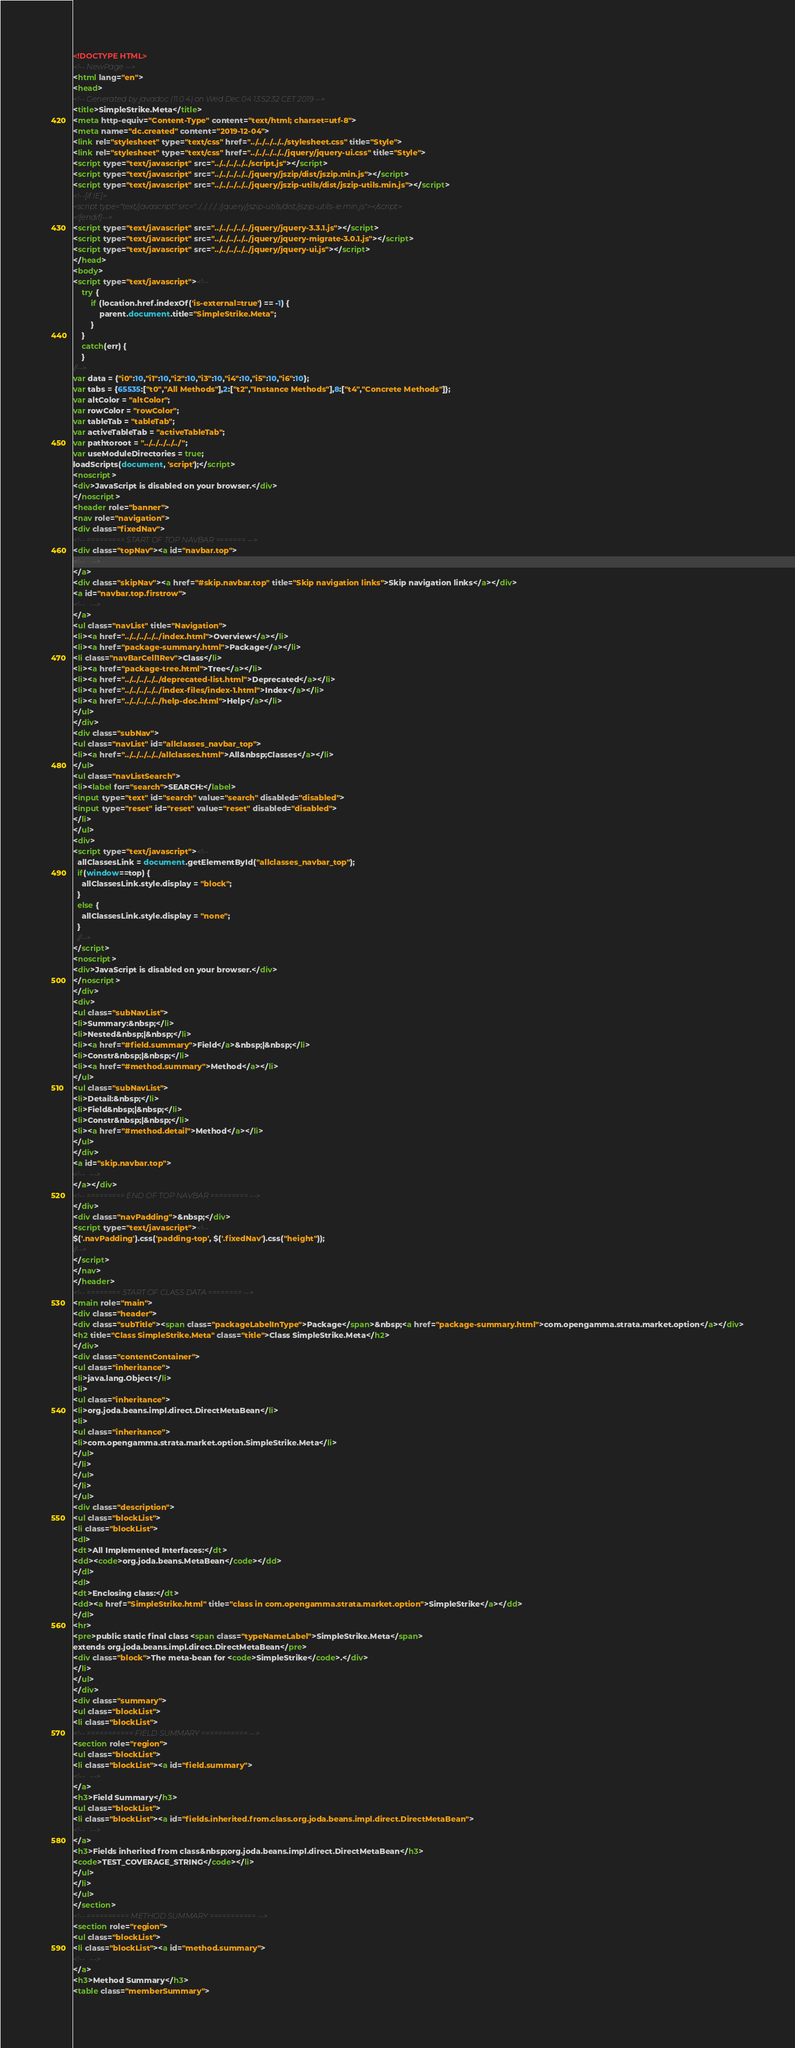Convert code to text. <code><loc_0><loc_0><loc_500><loc_500><_HTML_><!DOCTYPE HTML>
<!-- NewPage -->
<html lang="en">
<head>
<!-- Generated by javadoc (11.0.4) on Wed Dec 04 13:52:32 CET 2019 -->
<title>SimpleStrike.Meta</title>
<meta http-equiv="Content-Type" content="text/html; charset=utf-8">
<meta name="dc.created" content="2019-12-04">
<link rel="stylesheet" type="text/css" href="../../../../../stylesheet.css" title="Style">
<link rel="stylesheet" type="text/css" href="../../../../../jquery/jquery-ui.css" title="Style">
<script type="text/javascript" src="../../../../../script.js"></script>
<script type="text/javascript" src="../../../../../jquery/jszip/dist/jszip.min.js"></script>
<script type="text/javascript" src="../../../../../jquery/jszip-utils/dist/jszip-utils.min.js"></script>
<!--[if IE]>
<script type="text/javascript" src="../../../../../jquery/jszip-utils/dist/jszip-utils-ie.min.js"></script>
<![endif]-->
<script type="text/javascript" src="../../../../../jquery/jquery-3.3.1.js"></script>
<script type="text/javascript" src="../../../../../jquery/jquery-migrate-3.0.1.js"></script>
<script type="text/javascript" src="../../../../../jquery/jquery-ui.js"></script>
</head>
<body>
<script type="text/javascript"><!--
    try {
        if (location.href.indexOf('is-external=true') == -1) {
            parent.document.title="SimpleStrike.Meta";
        }
    }
    catch(err) {
    }
//-->
var data = {"i0":10,"i1":10,"i2":10,"i3":10,"i4":10,"i5":10,"i6":10};
var tabs = {65535:["t0","All Methods"],2:["t2","Instance Methods"],8:["t4","Concrete Methods"]};
var altColor = "altColor";
var rowColor = "rowColor";
var tableTab = "tableTab";
var activeTableTab = "activeTableTab";
var pathtoroot = "../../../../../";
var useModuleDirectories = true;
loadScripts(document, 'script');</script>
<noscript>
<div>JavaScript is disabled on your browser.</div>
</noscript>
<header role="banner">
<nav role="navigation">
<div class="fixedNav">
<!-- ========= START OF TOP NAVBAR ======= -->
<div class="topNav"><a id="navbar.top">
<!--   -->
</a>
<div class="skipNav"><a href="#skip.navbar.top" title="Skip navigation links">Skip navigation links</a></div>
<a id="navbar.top.firstrow">
<!--   -->
</a>
<ul class="navList" title="Navigation">
<li><a href="../../../../../index.html">Overview</a></li>
<li><a href="package-summary.html">Package</a></li>
<li class="navBarCell1Rev">Class</li>
<li><a href="package-tree.html">Tree</a></li>
<li><a href="../../../../../deprecated-list.html">Deprecated</a></li>
<li><a href="../../../../../index-files/index-1.html">Index</a></li>
<li><a href="../../../../../help-doc.html">Help</a></li>
</ul>
</div>
<div class="subNav">
<ul class="navList" id="allclasses_navbar_top">
<li><a href="../../../../../allclasses.html">All&nbsp;Classes</a></li>
</ul>
<ul class="navListSearch">
<li><label for="search">SEARCH:</label>
<input type="text" id="search" value="search" disabled="disabled">
<input type="reset" id="reset" value="reset" disabled="disabled">
</li>
</ul>
<div>
<script type="text/javascript"><!--
  allClassesLink = document.getElementById("allclasses_navbar_top");
  if(window==top) {
    allClassesLink.style.display = "block";
  }
  else {
    allClassesLink.style.display = "none";
  }
  //-->
</script>
<noscript>
<div>JavaScript is disabled on your browser.</div>
</noscript>
</div>
<div>
<ul class="subNavList">
<li>Summary:&nbsp;</li>
<li>Nested&nbsp;|&nbsp;</li>
<li><a href="#field.summary">Field</a>&nbsp;|&nbsp;</li>
<li>Constr&nbsp;|&nbsp;</li>
<li><a href="#method.summary">Method</a></li>
</ul>
<ul class="subNavList">
<li>Detail:&nbsp;</li>
<li>Field&nbsp;|&nbsp;</li>
<li>Constr&nbsp;|&nbsp;</li>
<li><a href="#method.detail">Method</a></li>
</ul>
</div>
<a id="skip.navbar.top">
<!--   -->
</a></div>
<!-- ========= END OF TOP NAVBAR ========= -->
</div>
<div class="navPadding">&nbsp;</div>
<script type="text/javascript"><!--
$('.navPadding').css('padding-top', $('.fixedNav').css("height"));
//-->
</script>
</nav>
</header>
<!-- ======== START OF CLASS DATA ======== -->
<main role="main">
<div class="header">
<div class="subTitle"><span class="packageLabelInType">Package</span>&nbsp;<a href="package-summary.html">com.opengamma.strata.market.option</a></div>
<h2 title="Class SimpleStrike.Meta" class="title">Class SimpleStrike.Meta</h2>
</div>
<div class="contentContainer">
<ul class="inheritance">
<li>java.lang.Object</li>
<li>
<ul class="inheritance">
<li>org.joda.beans.impl.direct.DirectMetaBean</li>
<li>
<ul class="inheritance">
<li>com.opengamma.strata.market.option.SimpleStrike.Meta</li>
</ul>
</li>
</ul>
</li>
</ul>
<div class="description">
<ul class="blockList">
<li class="blockList">
<dl>
<dt>All Implemented Interfaces:</dt>
<dd><code>org.joda.beans.MetaBean</code></dd>
</dl>
<dl>
<dt>Enclosing class:</dt>
<dd><a href="SimpleStrike.html" title="class in com.opengamma.strata.market.option">SimpleStrike</a></dd>
</dl>
<hr>
<pre>public static final class <span class="typeNameLabel">SimpleStrike.Meta</span>
extends org.joda.beans.impl.direct.DirectMetaBean</pre>
<div class="block">The meta-bean for <code>SimpleStrike</code>.</div>
</li>
</ul>
</div>
<div class="summary">
<ul class="blockList">
<li class="blockList">
<!-- =========== FIELD SUMMARY =========== -->
<section role="region">
<ul class="blockList">
<li class="blockList"><a id="field.summary">
<!--   -->
</a>
<h3>Field Summary</h3>
<ul class="blockList">
<li class="blockList"><a id="fields.inherited.from.class.org.joda.beans.impl.direct.DirectMetaBean">
<!--   -->
</a>
<h3>Fields inherited from class&nbsp;org.joda.beans.impl.direct.DirectMetaBean</h3>
<code>TEST_COVERAGE_STRING</code></li>
</ul>
</li>
</ul>
</section>
<!-- ========== METHOD SUMMARY =========== -->
<section role="region">
<ul class="blockList">
<li class="blockList"><a id="method.summary">
<!--   -->
</a>
<h3>Method Summary</h3>
<table class="memberSummary"></code> 